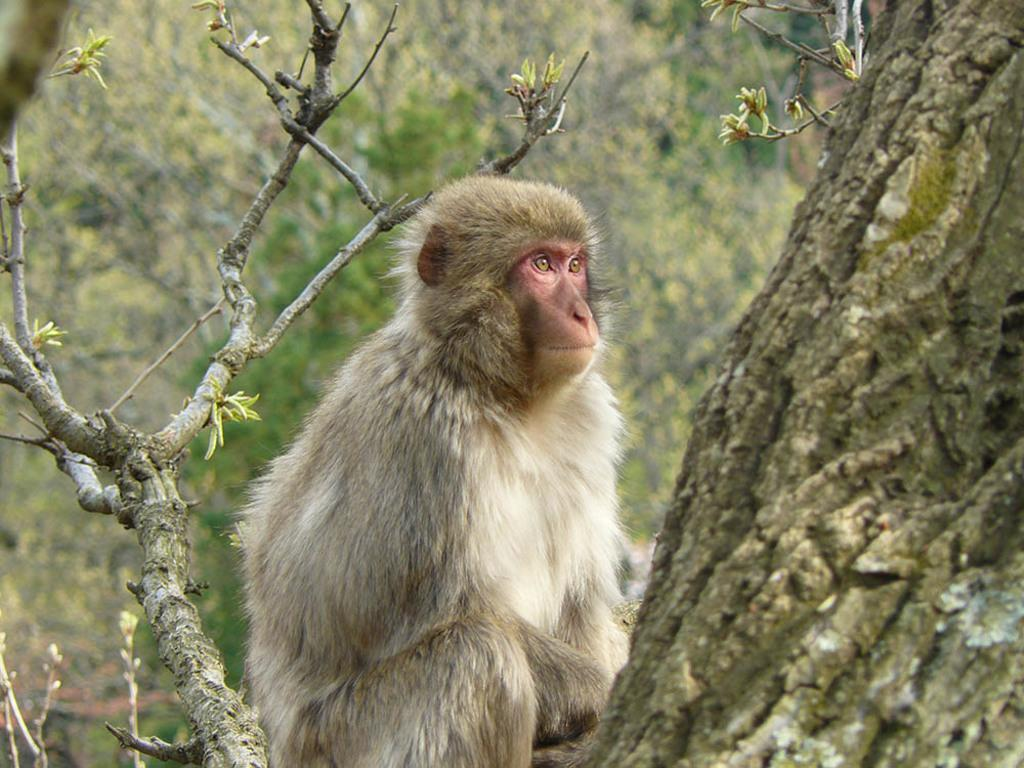What animal is present in the image? There is a monkey in the image. Where is the monkey located? The monkey is sitting on a tree branch. What part of the tree can be seen in the image? There is a tree trunk in the image. What type of vegetation is visible in the image? There are leaves in the image. How would you describe the background of the image? The background of the image appears blurry. Can you see the monkey wearing a crown in the image? No, the monkey is not wearing a crown in the image. Is there an airport visible in the background of the image? No, there is no airport present in the image. 